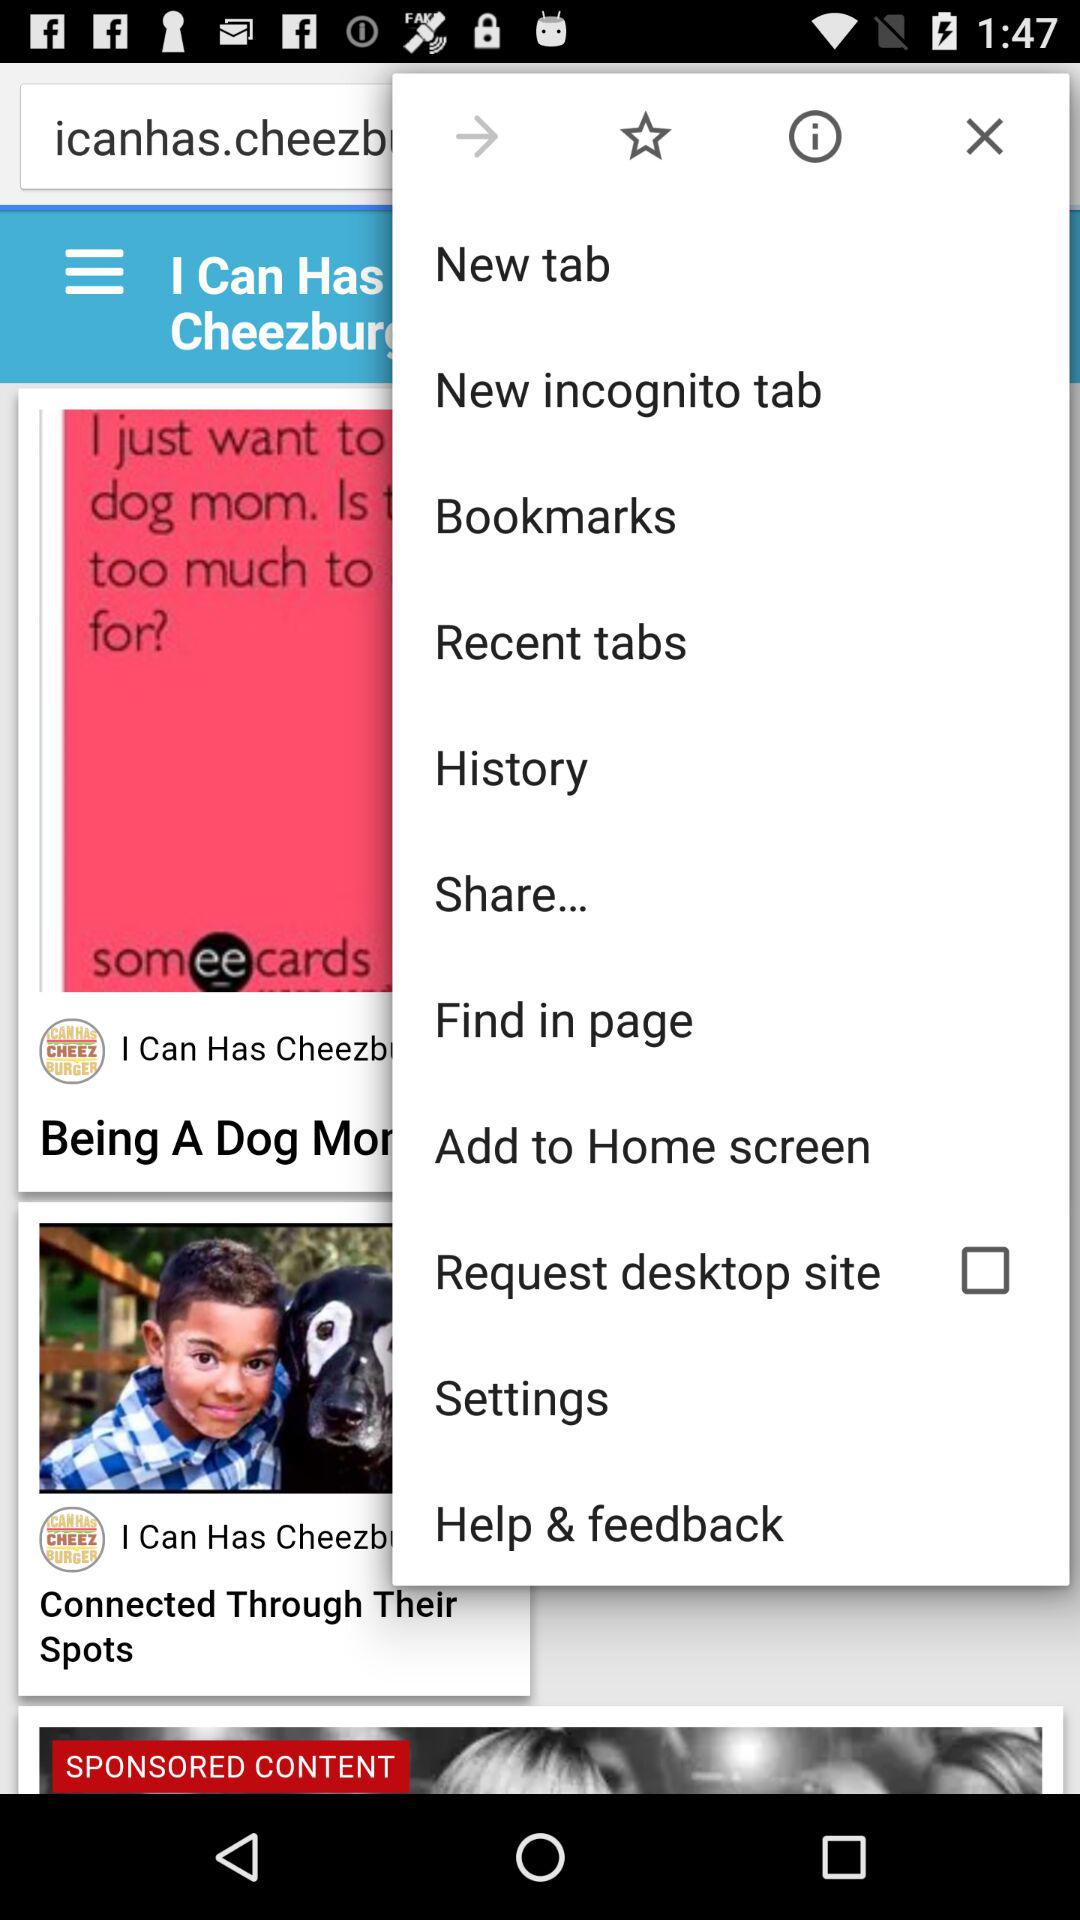What is the status of "Request desktop site"? The status of "Request desktop site" is "off". 